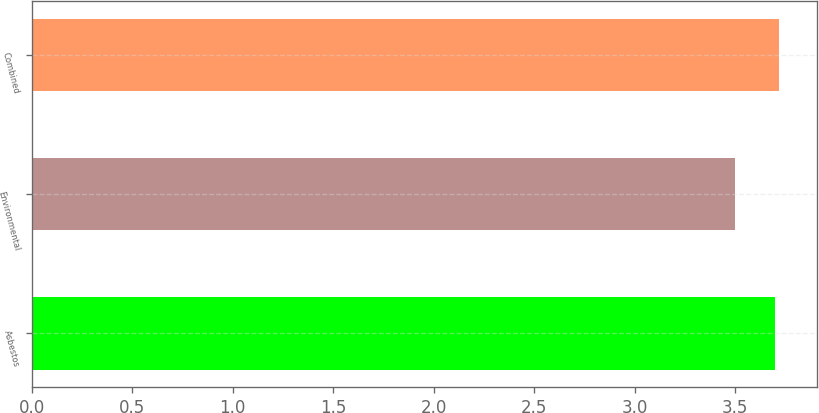Convert chart to OTSL. <chart><loc_0><loc_0><loc_500><loc_500><bar_chart><fcel>Asbestos<fcel>Environmental<fcel>Combined<nl><fcel>3.7<fcel>3.5<fcel>3.72<nl></chart> 